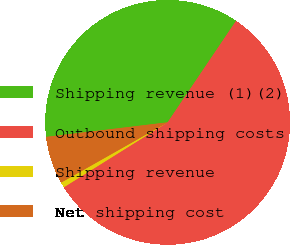<chart> <loc_0><loc_0><loc_500><loc_500><pie_chart><fcel>Shipping revenue (1)(2)<fcel>Outbound shipping costs<fcel>Shipping revenue<fcel>Net shipping cost<nl><fcel>36.34%<fcel>56.66%<fcel>0.7%<fcel>6.3%<nl></chart> 